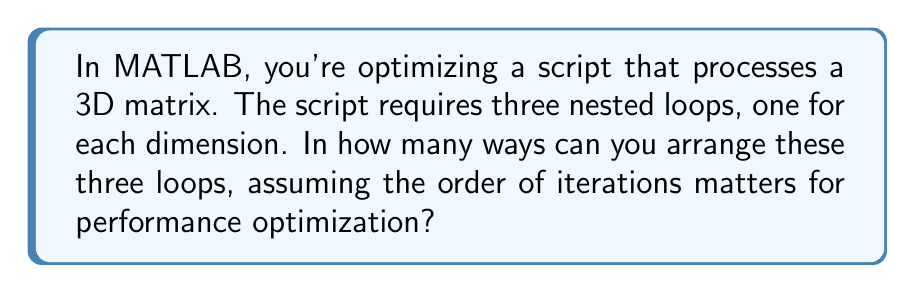Teach me how to tackle this problem. Let's approach this step-by-step:

1) We have three loops to arrange, one for each dimension of the 3D matrix. Let's call them x, y, and z.

2) This is a permutation problem, as the order matters for performance optimization.

3) The number of permutations of n distinct objects is given by the formula:

   $$P(n) = n!$$

4) In this case, n = 3 (three loops to arrange).

5) Therefore, the number of possible arrangements is:

   $$P(3) = 3! = 3 \times 2 \times 1 = 6$$

6) We can list out these 6 arrangements explicitly:
   - xyz
   - xzy
   - yxz
   - yzx
   - zxy
   - zyx

Each of these represents a different way to nest the loops in the MATLAB script, potentially affecting the performance due to factors like memory access patterns.
Answer: 6 